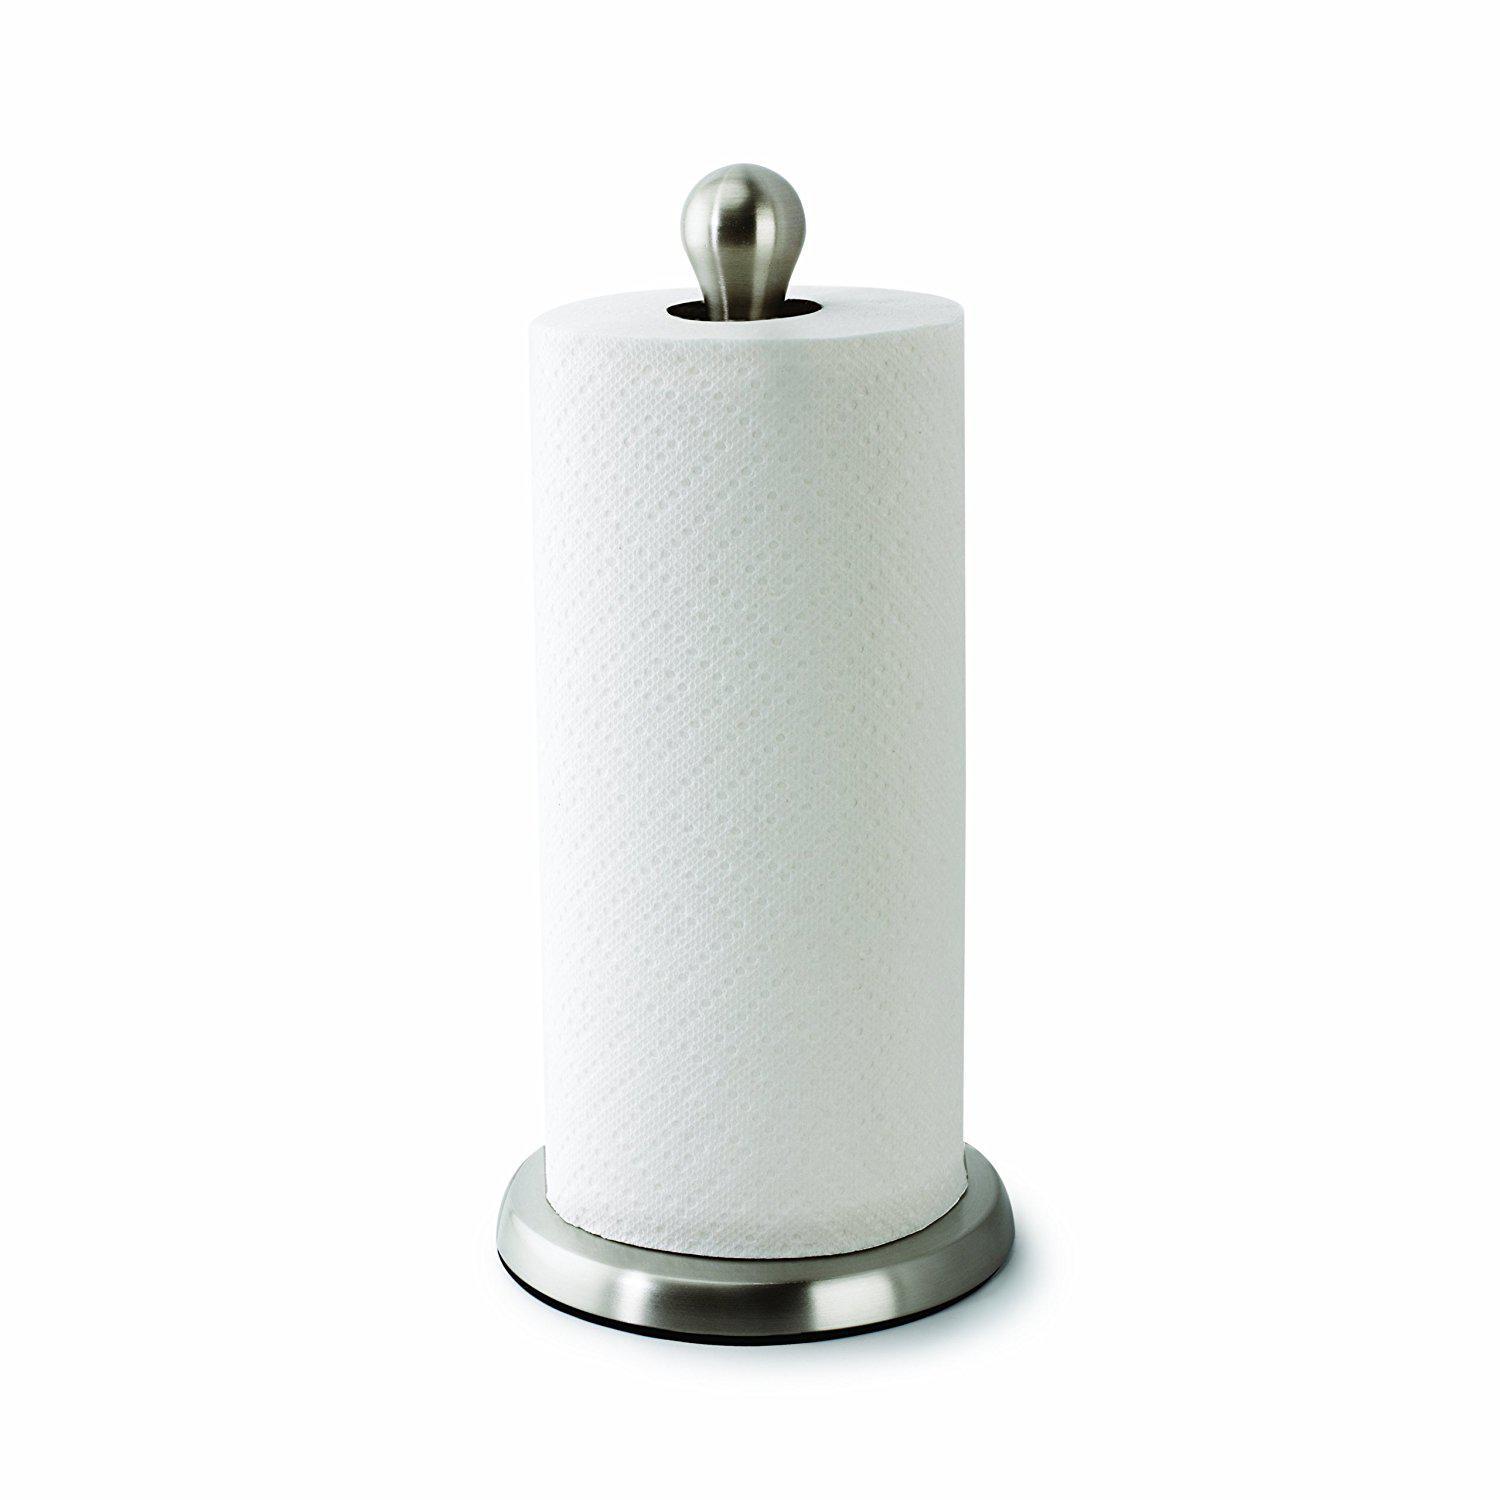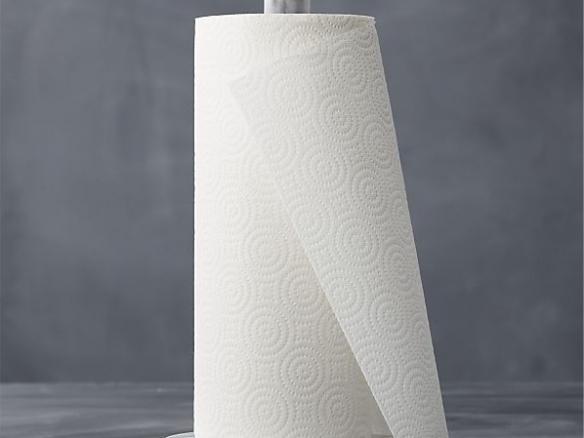The first image is the image on the left, the second image is the image on the right. For the images displayed, is the sentence "Only one roll is shown on a stand holder." factually correct? Answer yes or no. No. 